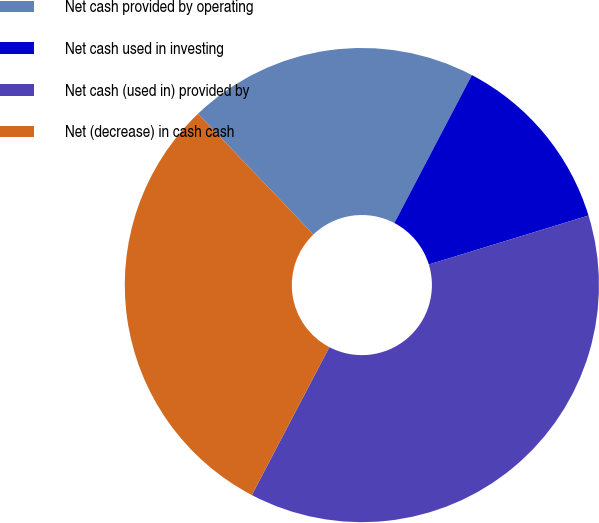Convert chart to OTSL. <chart><loc_0><loc_0><loc_500><loc_500><pie_chart><fcel>Net cash provided by operating<fcel>Net cash used in investing<fcel>Net cash (used in) provided by<fcel>Net (decrease) in cash cash<nl><fcel>19.83%<fcel>12.58%<fcel>37.42%<fcel>30.17%<nl></chart> 